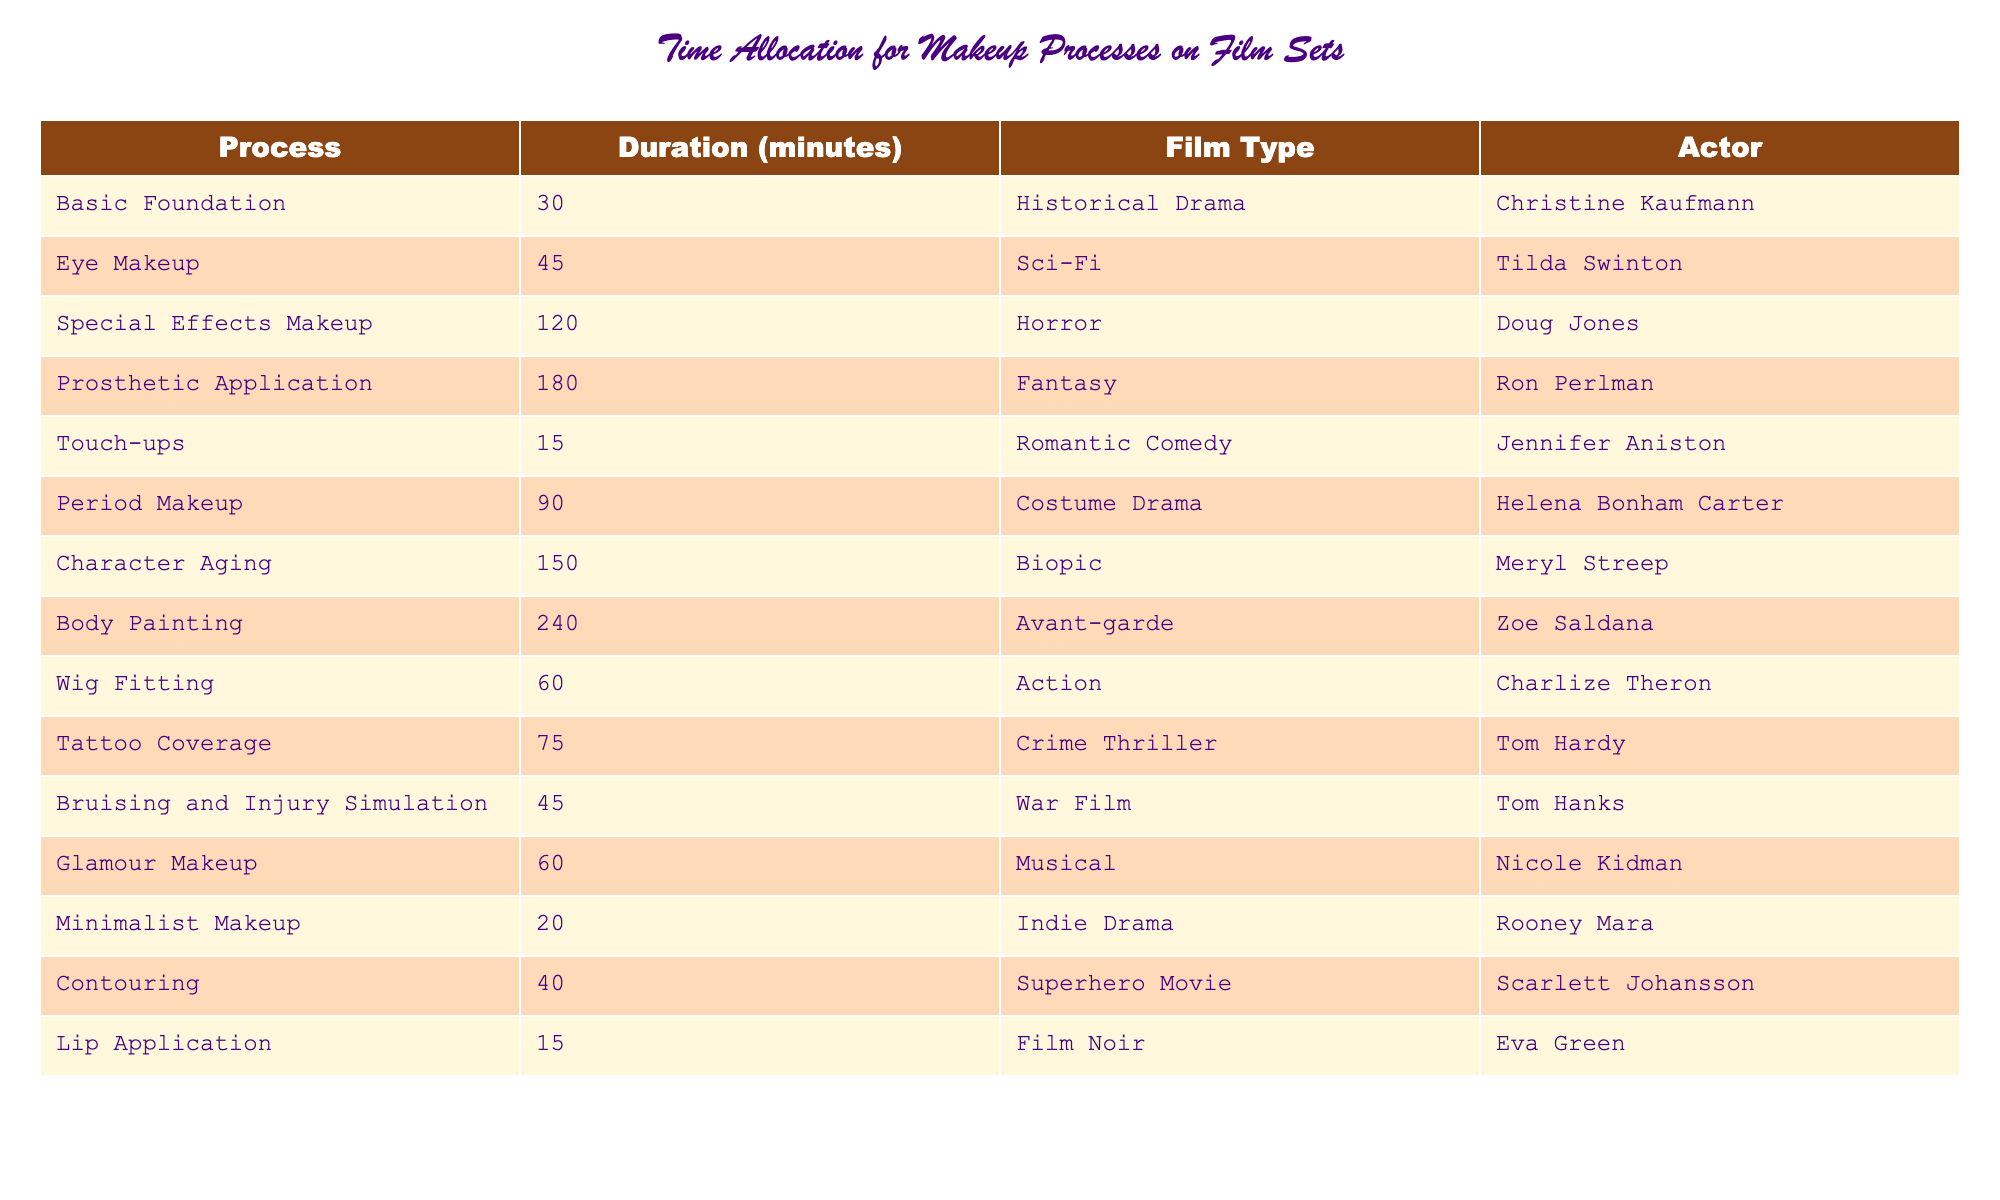What is the longest makeup process listed in the table? The table shows various makeup processes along with their durations. Scanning through the "Duration (minutes)" column, the longest duration belongs to "Body Painting," which is 240 minutes.
Answer: Body Painting How much time does 'Character Aging' take compared to 'Touch-ups'? 'Character Aging' takes 150 minutes, and 'Touch-ups' take 15 minutes. The difference is calculated as 150 - 15 = 135 minutes. Therefore, 'Character Aging' takes 135 minutes longer than 'Touch-ups'.
Answer: 135 minutes Which film type requires the least amount of makeup application time? Reviewing the durations for each film type in the table, 'Romantic Comedy' requires the least amount of application time with 'Touch-ups' at 15 minutes.
Answer: Romantic Comedy Is the duration for 'Eye Makeup' longer than the duration for 'Glamour Makeup'? 'Eye Makeup' takes 45 minutes, while 'Glamour Makeup' takes 60 minutes. Since 45 is not greater than 60, 'Eye Makeup' is not longer.
Answer: No What is the average duration of the makeup processes for the listed film types? To find the average, we sum up all durations: 30 + 45 + 120 + 180 + 15 + 90 + 150 + 240 + 60 + 75 + 45 + 60 + 20 + 40 + 15 = 1,890 minutes. There are 15 processes total, so we find the average by dividing 1,890 by 15, which gives us 126 minutes.
Answer: 126 minutes Which actor has the highest single makeup application time? Looking at the table, 'Prosthetic Application' for Ron Perlman is the highest at 180 minutes. No other actor's process exceeds this time.
Answer: Ron Perlman How many makeup processes are longer than 90 minutes? By checking the durations in the table, the processes longer than 90 minutes are 'Special Effects Makeup' (120), 'Prosthetic Application' (180), 'Character Aging' (150), and 'Body Painting' (240), totaling 4 processes.
Answer: 4 processes Which film type has the shortest makeup process and how long does it take? Scanning the table shows that 'Romantic Comedy' with 'Touch-ups' is the shortest process at 15 minutes.
Answer: 15 minutes Is 'Tattoo Coverage' always longer than 'Eye Makeup'? 'Tattoo Coverage' is 75 minutes, while 'Eye Makeup' is 45 minutes. Since 75 is indeed greater than 45, 'Tattoo Coverage' is always longer.
Answer: Yes What are the total durations for all historical and drama-type films listed? Identifying the films that fit are 'Historical Drama' (30 minutes), 'Costume Drama' (90 minutes), and 'Biopic' (150 minutes). The total of these durations is 30 + 90 + 150 = 270 minutes.
Answer: 270 minutes 